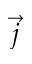<formula> <loc_0><loc_0><loc_500><loc_500>\vec { j }</formula> 